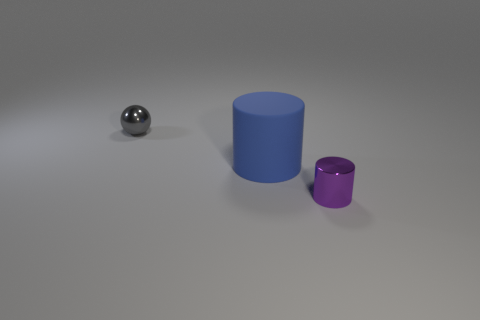Add 3 tiny things. How many objects exist? 6 Subtract all spheres. How many objects are left? 2 Subtract 0 green spheres. How many objects are left? 3 Subtract all small purple metal objects. Subtract all big matte things. How many objects are left? 1 Add 3 blue rubber objects. How many blue rubber objects are left? 4 Add 3 metallic cylinders. How many metallic cylinders exist? 4 